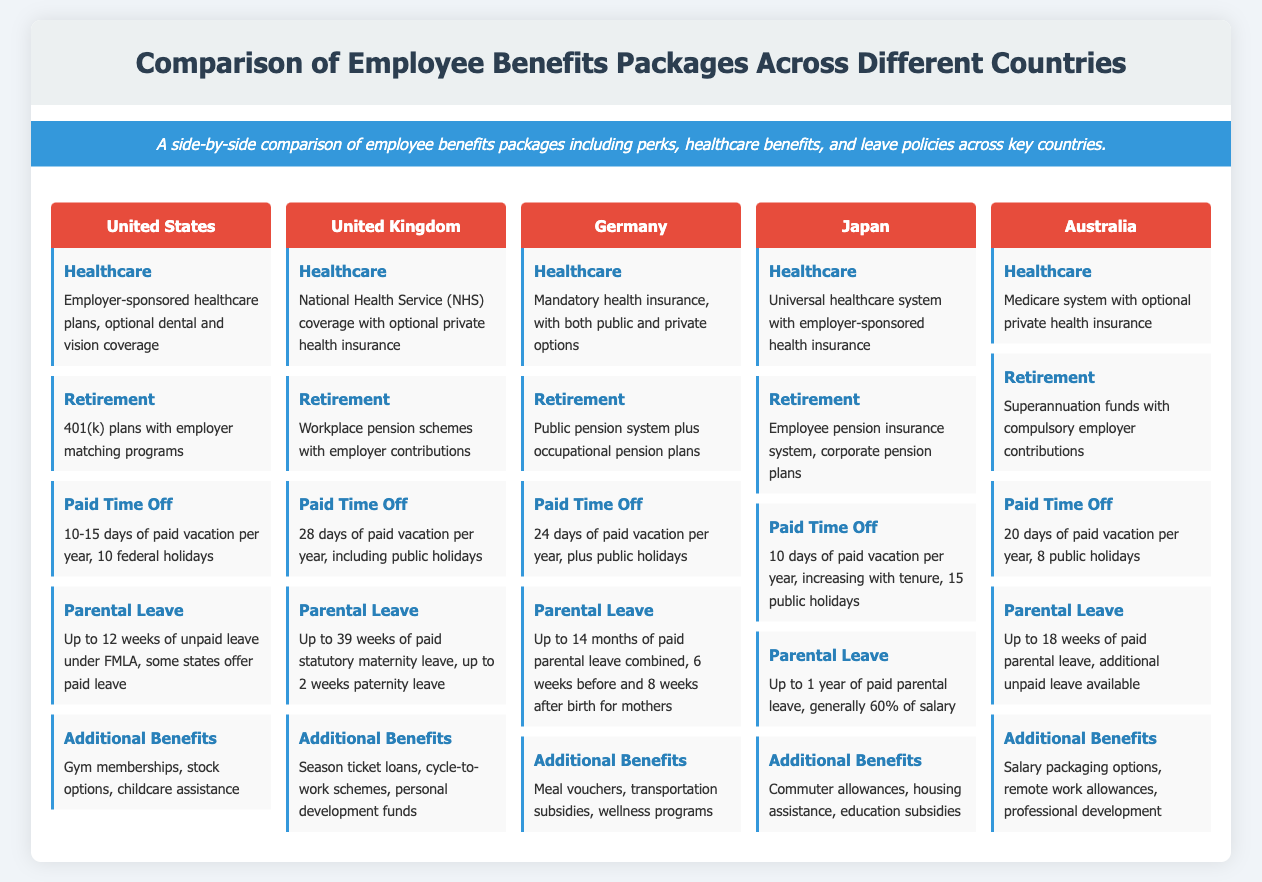What is the paid vacation days in the United Kingdom? The paid vacation days in the United Kingdom are specified in the 'Paid Time Off' section, which states there are 28 days of paid vacation per year.
Answer: 28 days What type of healthcare system is in Japan? The type of healthcare system in Japan is mentioned in the 'Healthcare' section, indicating a universal healthcare system with employer-sponsored health insurance.
Answer: Universal healthcare system How many weeks of paid parental leave does Australia offer? Australia's paid parental leave is noted in the 'Parental Leave' section, which mentions up to 18 weeks of paid parental leave.
Answer: 18 weeks What additional benefits does Germany provide? Germany's additional benefits are outlined in the 'Additional Benefits' section and include meal vouchers, transportation subsidies, and wellness programs.
Answer: Meal vouchers, transportation subsidies, wellness programs Which country has the least paid vacation days? The paid vacation days in each country can be compared, and it shows that Japan has 10 days listed under 'Paid Time Off,' which is the least.
Answer: Japan 